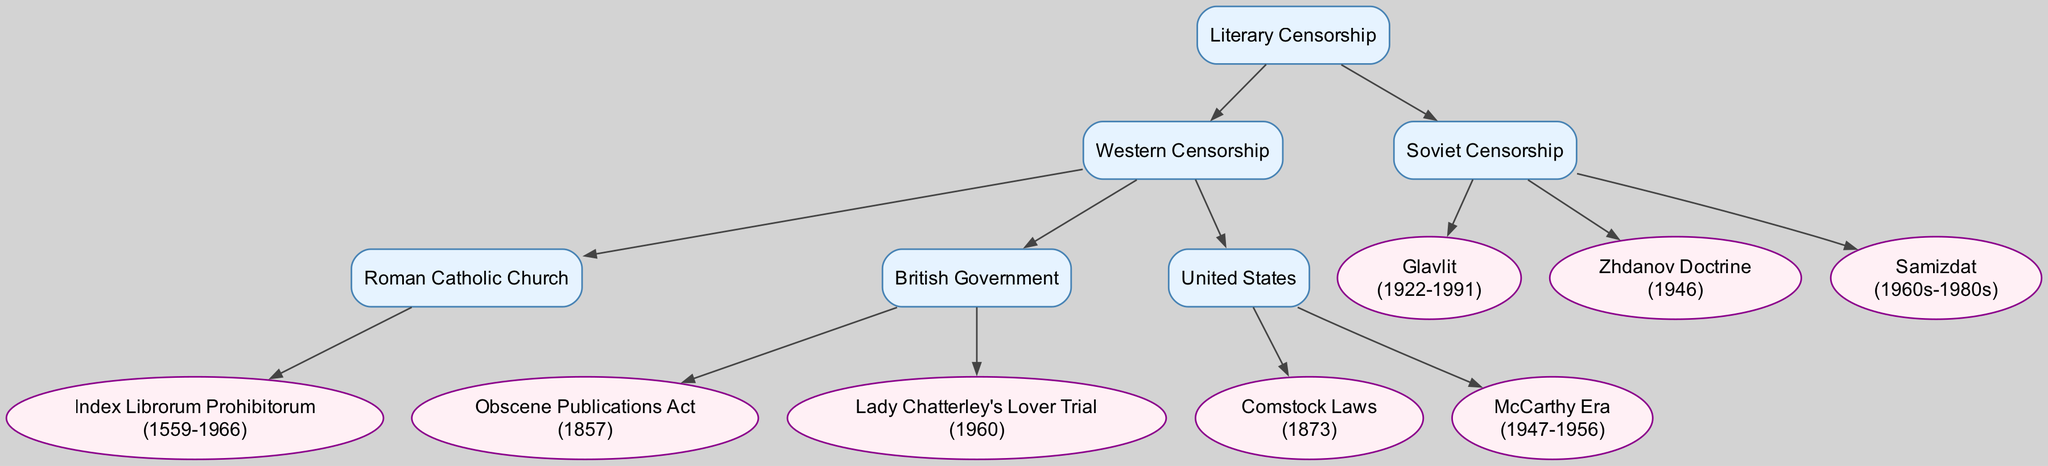What is the main category of the diagram? The top node of the diagram clearly indicates that the overall focus is on "Literary Censorship." It serves as the main category under which all other nodes are organized.
Answer: Literary Censorship How many main branches are present in the diagram? The diagram consists of two main branches: "Western Censorship" and "Soviet Censorship." Each represents a distinctive approach to literary censorship within their respective cultural contexts.
Answer: 2 What was the duration of the Index Librorum Prohibitorum? This particular node indicates the years of operation for the Index Librorum Prohibitorum, which are shown as "1559-1966."
Answer: 1559-1966 Which organization is associated with the years 1922-1991? The node labeled "Glavlit" in Soviet Censorship specifies these years, indicating the time frame for this censorship body.
Answer: Glavlit What legal act did the British Government enact in 1857? The diagram shows a node detailing the "Obscene Publications Act," which was enacted by the British Government in that year.
Answer: Obscene Publications Act Which censorship body is linked with the Zhdanov Doctrine? The Zhdanov Doctrine is specifically listed under the Soviet Censorship category, pointing to a notable period of artistic control in Soviet literature.
Answer: Zhdanov Doctrine What is the relationship between Western and Soviet Censorship in the diagram? The diagram illustrates that both branches stem from the main concept of "Literary Censorship," indicating they are two principal forms or perspectives on censorship within literature.
Answer: Sibling branches How many specific instances of censorship are listed under the United States? Under the "United States" branch, there are two listed instances: "Comstock Laws" and "McCarthy Era," thus totaling two specific cases of censorship mentioned.
Answer: 2 What decade did Samizdat primarily occur? The node for "Samizdat" specifies the timeframe as "1960s-1980s," which identifies the decades when this alternative publishing method was prevalent in the Soviet Union.
Answer: 1960s-1980s 